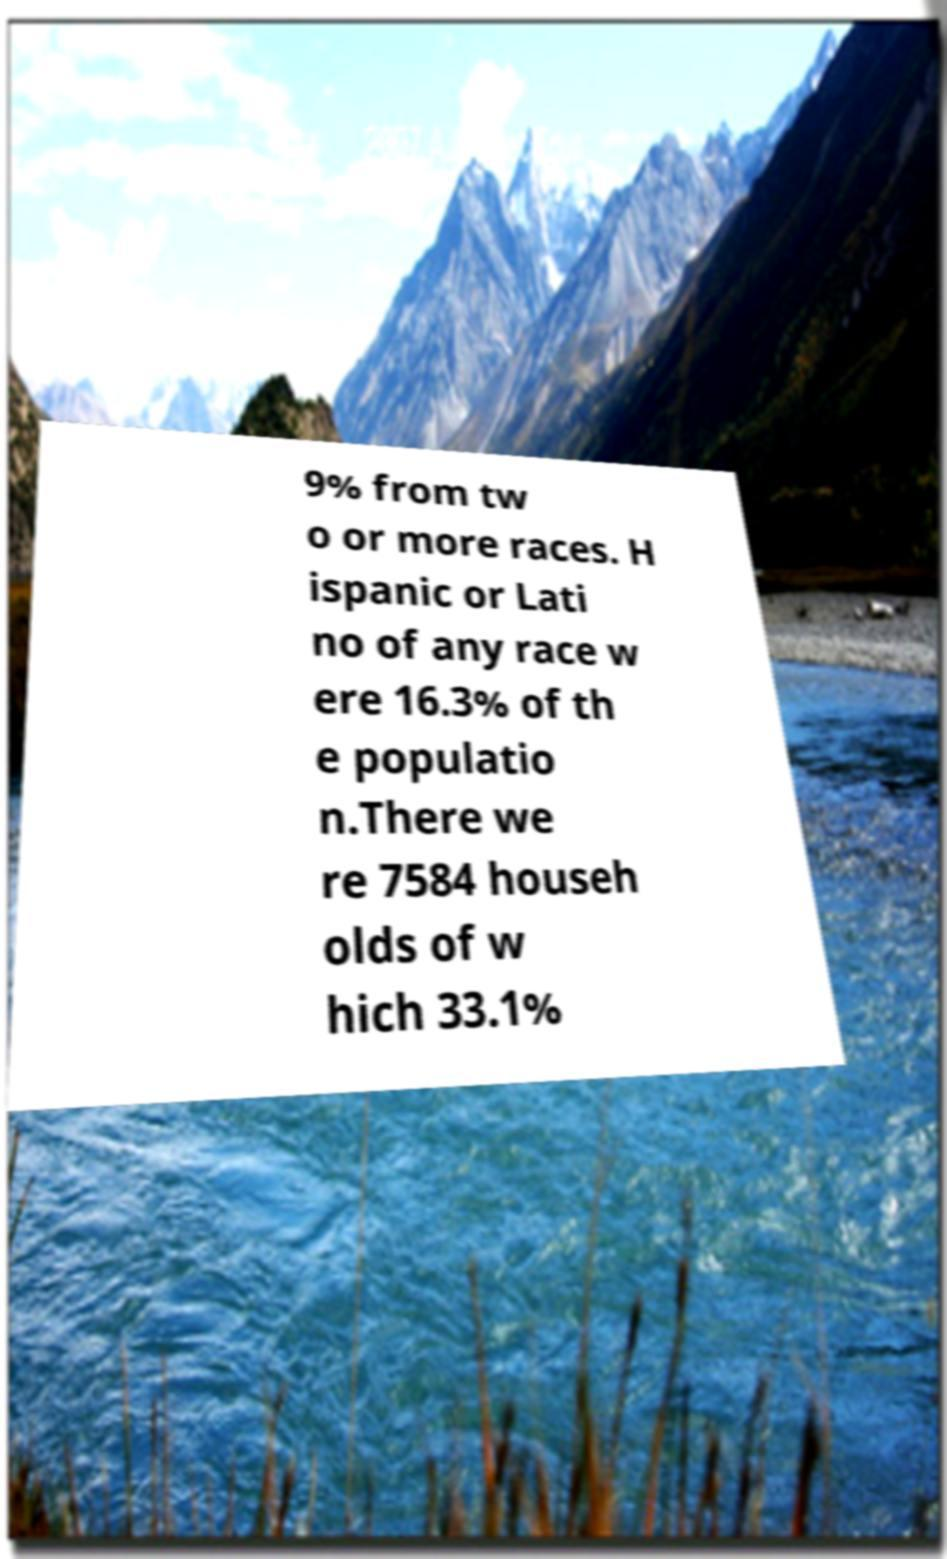I need the written content from this picture converted into text. Can you do that? 9% from tw o or more races. H ispanic or Lati no of any race w ere 16.3% of th e populatio n.There we re 7584 househ olds of w hich 33.1% 